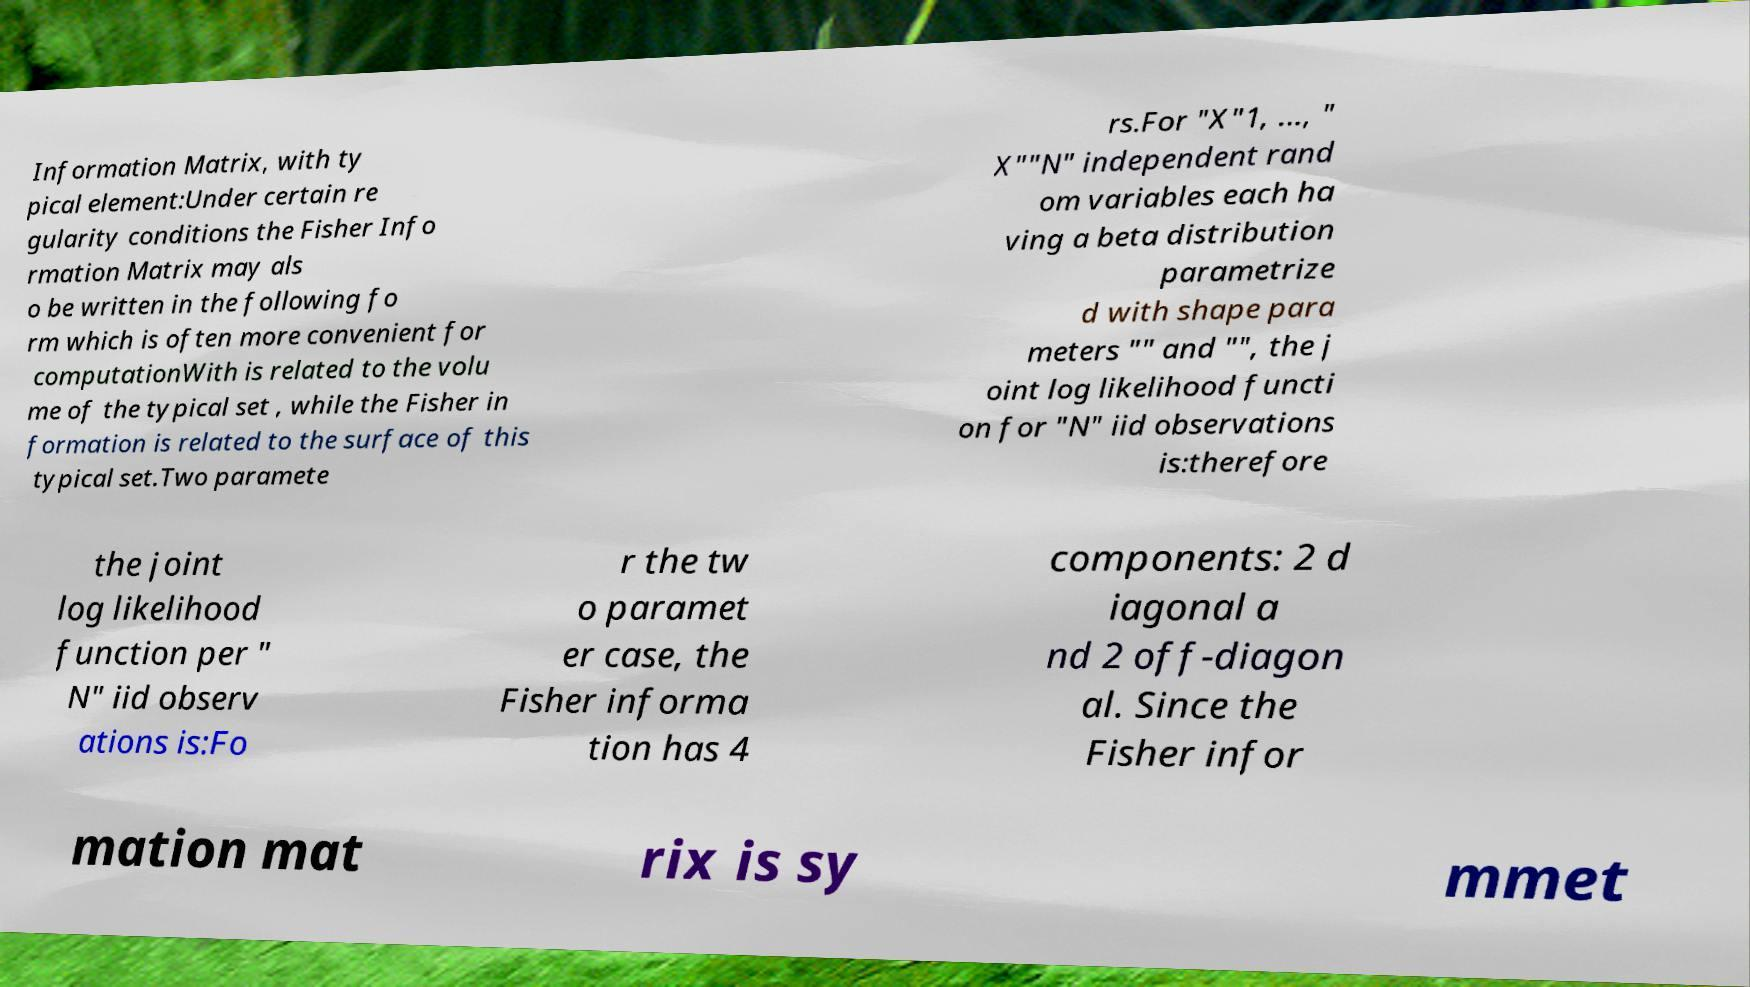For documentation purposes, I need the text within this image transcribed. Could you provide that? Information Matrix, with ty pical element:Under certain re gularity conditions the Fisher Info rmation Matrix may als o be written in the following fo rm which is often more convenient for computationWith is related to the volu me of the typical set , while the Fisher in formation is related to the surface of this typical set.Two paramete rs.For "X"1, ..., " X""N" independent rand om variables each ha ving a beta distribution parametrize d with shape para meters "" and "", the j oint log likelihood functi on for "N" iid observations is:therefore the joint log likelihood function per " N" iid observ ations is:Fo r the tw o paramet er case, the Fisher informa tion has 4 components: 2 d iagonal a nd 2 off-diagon al. Since the Fisher infor mation mat rix is sy mmet 